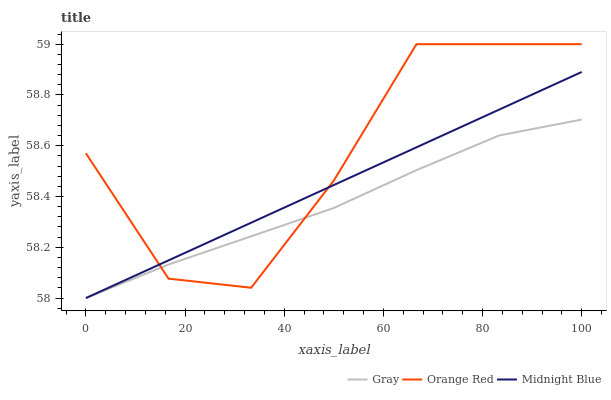Does Gray have the minimum area under the curve?
Answer yes or no. Yes. Does Orange Red have the maximum area under the curve?
Answer yes or no. Yes. Does Midnight Blue have the minimum area under the curve?
Answer yes or no. No. Does Midnight Blue have the maximum area under the curve?
Answer yes or no. No. Is Midnight Blue the smoothest?
Answer yes or no. Yes. Is Orange Red the roughest?
Answer yes or no. Yes. Is Orange Red the smoothest?
Answer yes or no. No. Is Midnight Blue the roughest?
Answer yes or no. No. Does Gray have the lowest value?
Answer yes or no. Yes. Does Orange Red have the lowest value?
Answer yes or no. No. Does Orange Red have the highest value?
Answer yes or no. Yes. Does Midnight Blue have the highest value?
Answer yes or no. No. Does Midnight Blue intersect Orange Red?
Answer yes or no. Yes. Is Midnight Blue less than Orange Red?
Answer yes or no. No. Is Midnight Blue greater than Orange Red?
Answer yes or no. No. 